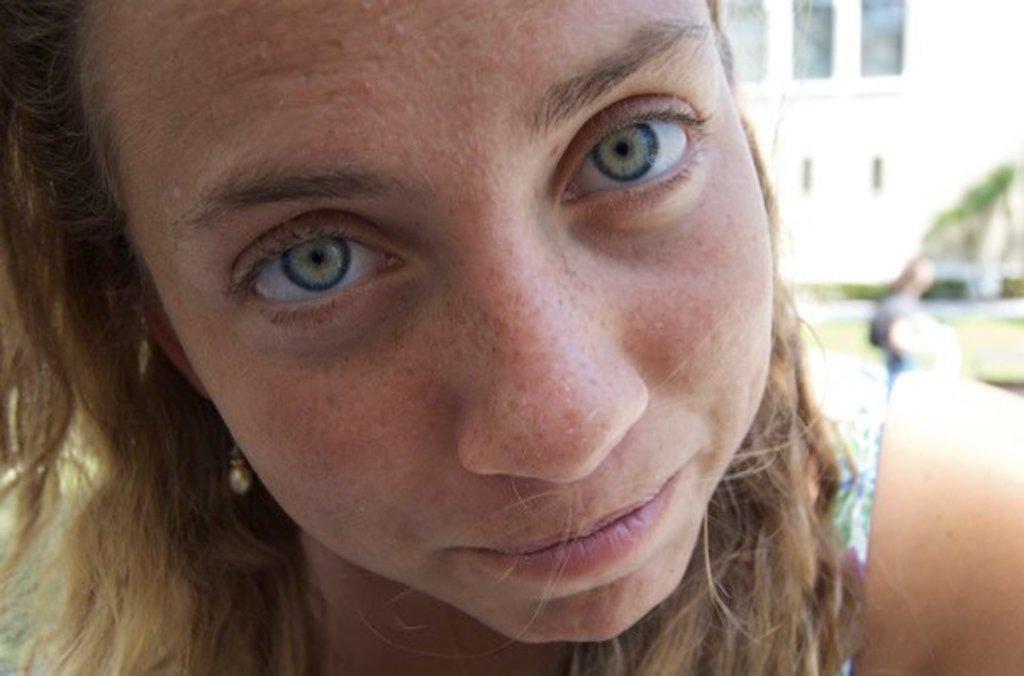Please provide a concise description of this image. In this picture there is a woman who is wearing white dress. On the right there is another woman who is standing on the road. in the background we can see the building, door, plants and grass. 